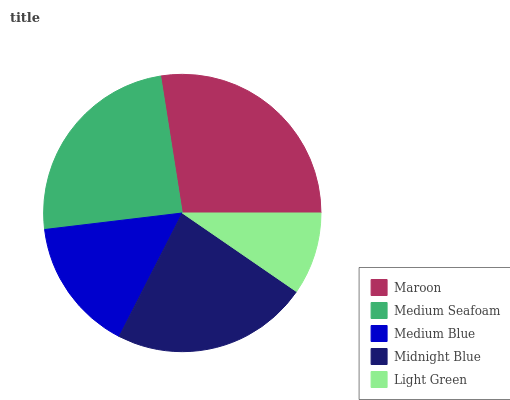Is Light Green the minimum?
Answer yes or no. Yes. Is Maroon the maximum?
Answer yes or no. Yes. Is Medium Seafoam the minimum?
Answer yes or no. No. Is Medium Seafoam the maximum?
Answer yes or no. No. Is Maroon greater than Medium Seafoam?
Answer yes or no. Yes. Is Medium Seafoam less than Maroon?
Answer yes or no. Yes. Is Medium Seafoam greater than Maroon?
Answer yes or no. No. Is Maroon less than Medium Seafoam?
Answer yes or no. No. Is Midnight Blue the high median?
Answer yes or no. Yes. Is Midnight Blue the low median?
Answer yes or no. Yes. Is Medium Blue the high median?
Answer yes or no. No. Is Light Green the low median?
Answer yes or no. No. 